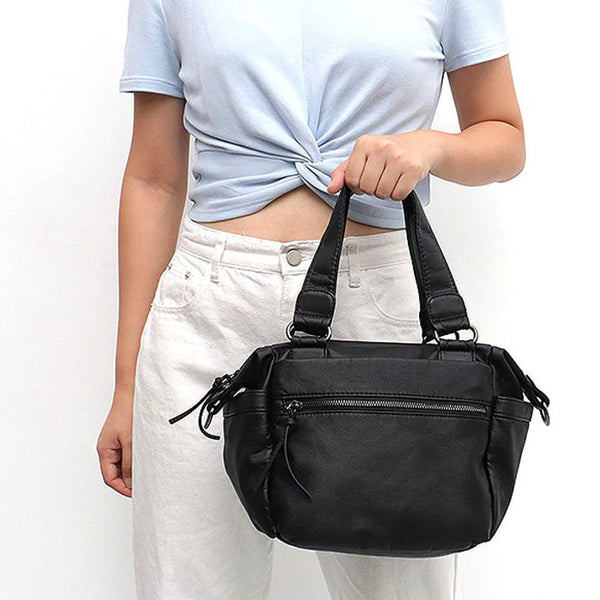If this handbag could talk, what stories would it tell about its owner? If this handbag could talk, it might share tales of curated daily adventures—like the early morning coffee runs where the owner grabs a fresh croissant, the bustling downtown streets navigated with confidence, or the creative brainstorming sessions at a trendy cafe where the handbag rests beside her laptop. It would recount spontaneous shopping sprees, evenings spent at cozy bookstores, and even weekend getaways where it carries just the essentials, highlighting its role as a reliable companion in both mundane routines and exciting escapades. How would you describe the potential lifestyle of someone who chooses to carry this handbag? Someone who chooses this handbag likely values both style and practicality. They lead an active lifestyle, whether it's a bustling urbanite navigating through city life or a multitasker balancing professional and personal commitments. They appreciate the blend of chic design and functional features, ensuring they are prepared for anything the day may bring. This person is likely organized, detail-oriented, and has an eye for fashion, seamlessly merging their need for utility with their desire for a polished look. Imagine an extremely creative use case for this handbag that goes beyond traditional functions. In a fantastical twist, envision that the handbag contains a hidden compartment that leads to a miniature, magical world. Whenever the owner reaches inside, they discover whimsical objects or creatures that assist them in their daily tasks—like a tiny, animated pencil that takes notes during meetings or a small, friendly sprite that organizes their belongings. This enchanted handbag not only holds essential items but also adds a touch of magic and surprise to everyday life, making mundane activities extraordinary. Provide a realistic scenario where this handbag's features make a noticeable difference. On a busy morning, the owner is rushing to catch the train to work. Thanks to the handbag's easily accessible external pocket, she quickly retrieves her transit card without having to rummage through the main compartment. Later in the day, during a lunch meeting, she effortlessly finds her notepad and pen, thanks to the organized space of the main compartment. The handbag's practical design significantly reduces the stress of losing important items and enhances her efficiency throughout the day. What kind of outfits would this handbag complement? This handbag would complement a wide range of outfits due to its versatile and classic black design. It can effortlessly enhance a casual ensemble such as jeans and a blouse, provide a sleek touch to a business casual look with tailored pants and a blazer, or add a refined element to a chic dress and heels for a night out. Its adaptable style makes it a perfect accessory for various occasions, ensuring the owner always appears stylish and put-together. 